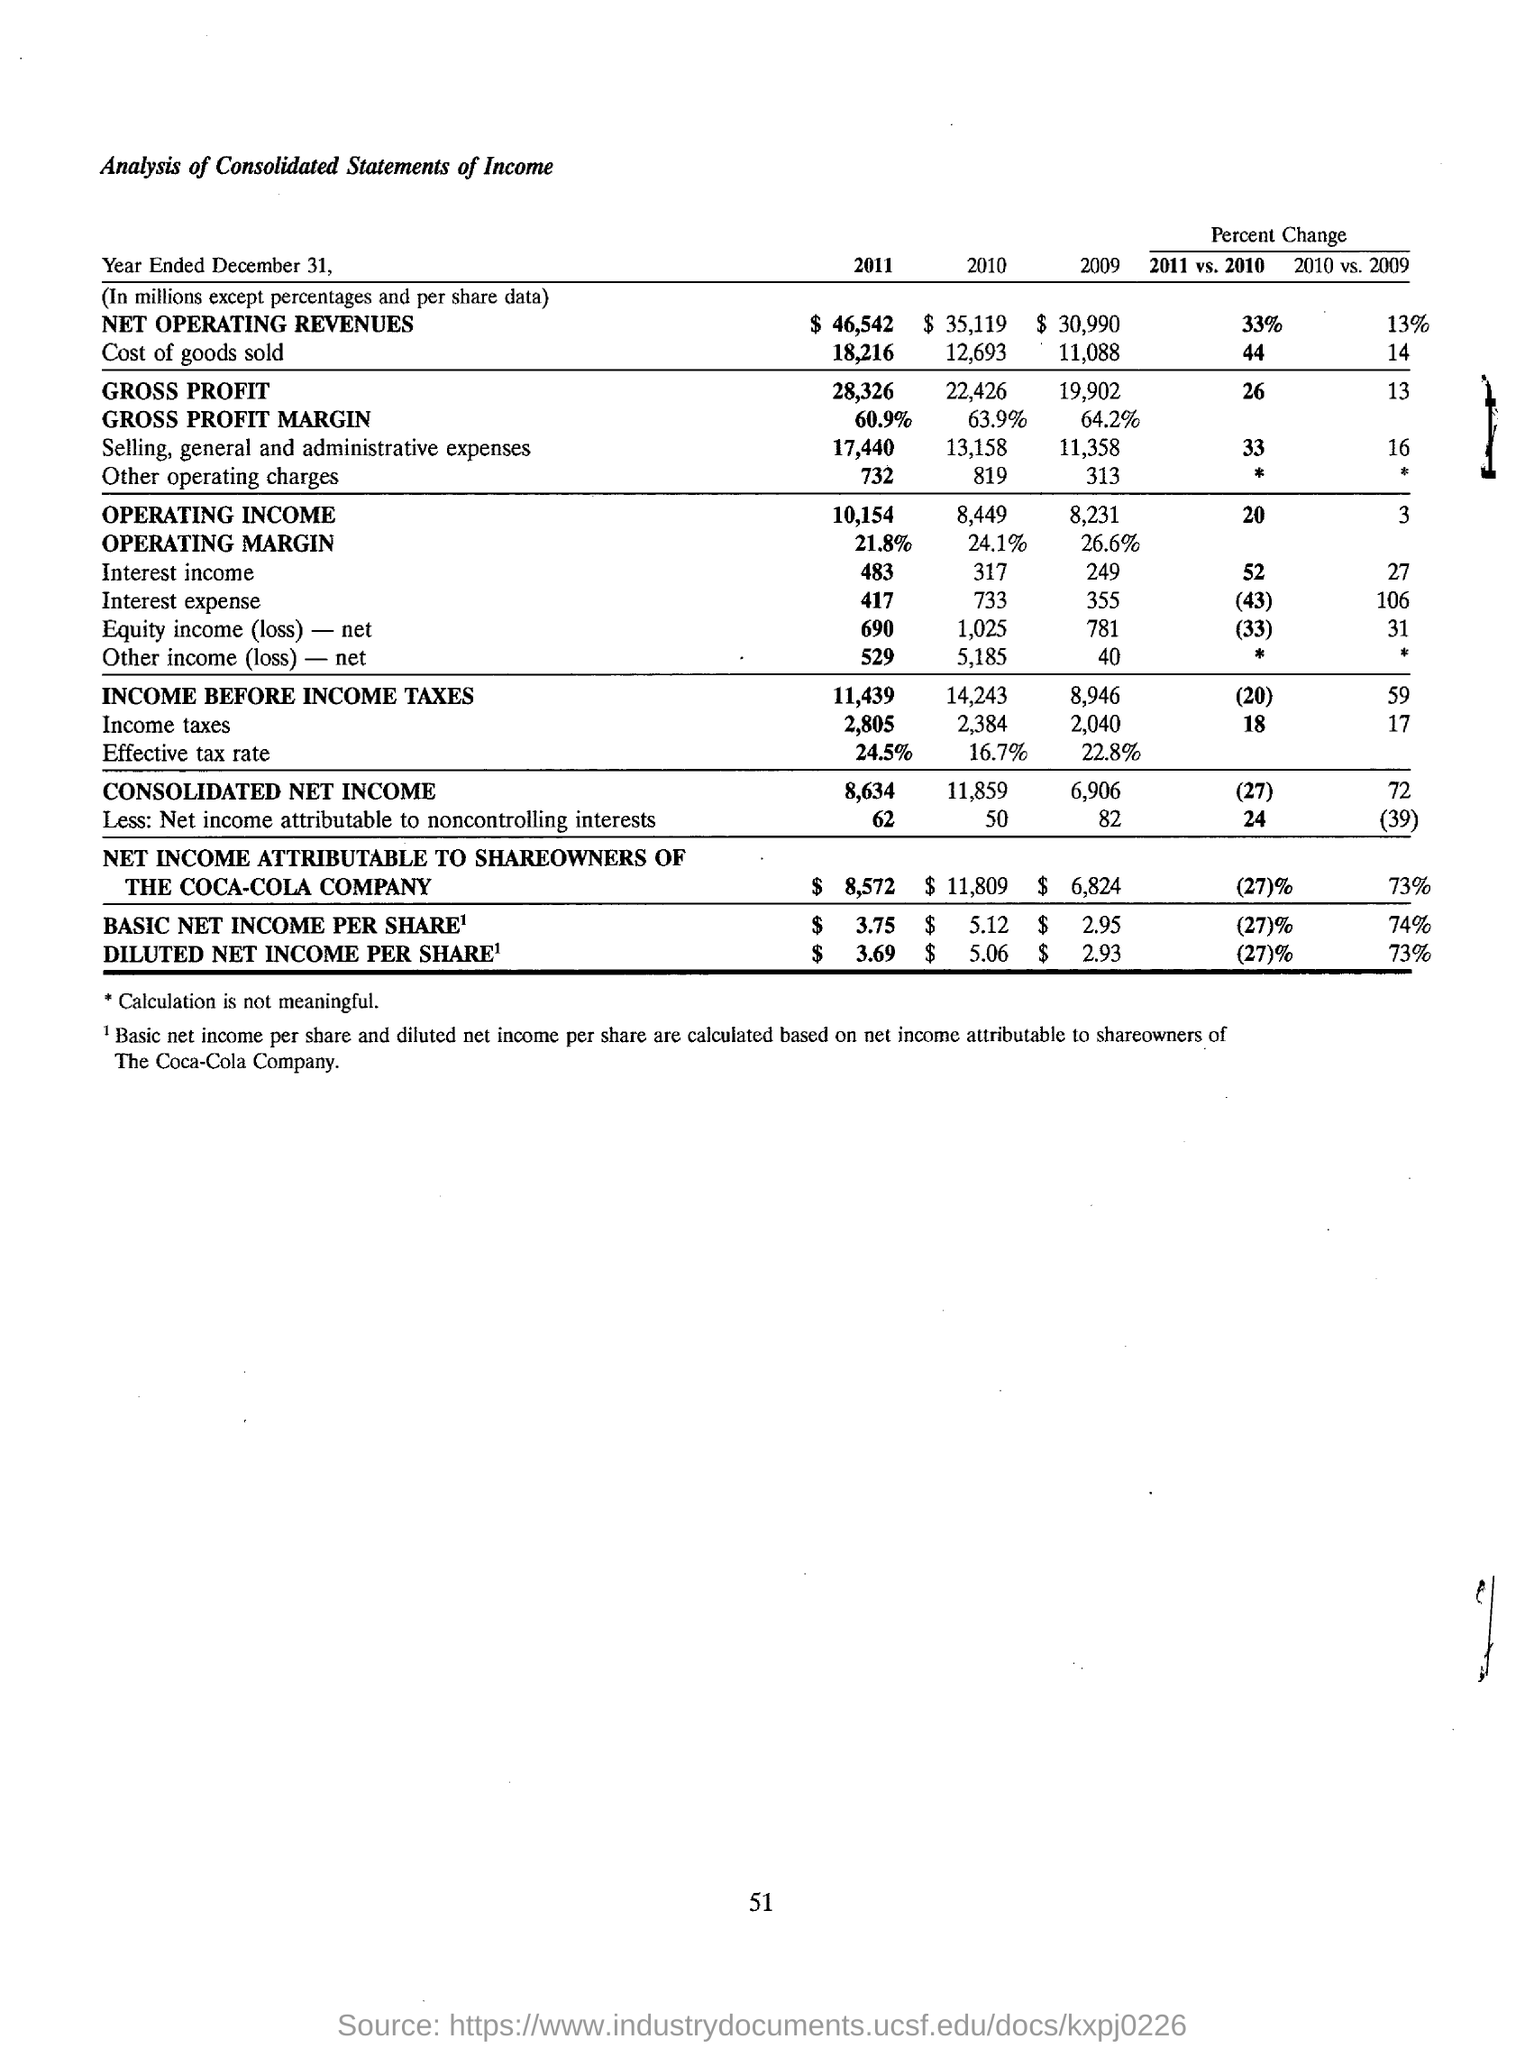Indicate a few pertinent items in this graphic. The basic net income per share and diluted net income per share of The Coca-Cola Company are calculated based on its net income attributable to shareowners. The basic net income per share for the year 2011 was $3.75. The consolidated net income for the year 2011 was 8,634. The net operating revenues for the year 2010 were 35 and 119, respectively. For the year 2009, the gross profit margin was 64.2%. 